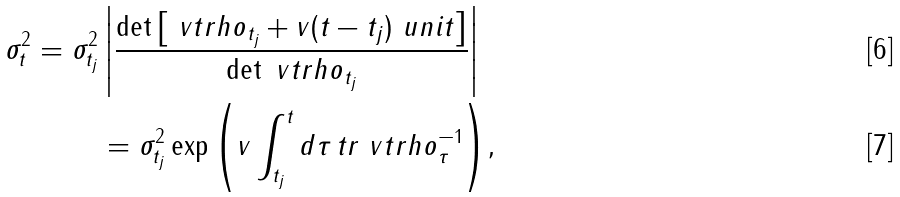<formula> <loc_0><loc_0><loc_500><loc_500>\sigma _ { t } ^ { 2 } = \sigma _ { t _ { j } } ^ { 2 } & \left | \frac { \det \left [ \ v t r h o _ { t _ { j } } + v ( t - t _ { j } ) \ u n i t \right ] } { \det \ v t r h o _ { t _ { j } } } \right | \\ & = \sigma _ { t _ { j } } ^ { 2 } \exp { \left ( v \real \int _ { t _ { j } } ^ { t } d \tau \, t r \ v t r h o _ { \tau } ^ { - 1 } \right ) } ,</formula> 